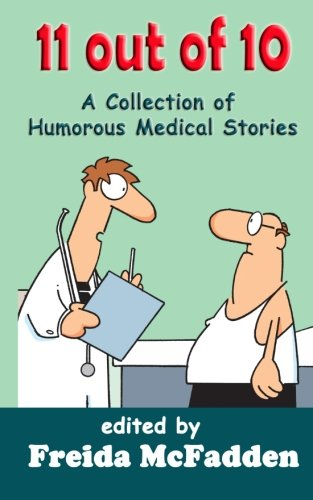Could you suggest similar books or genres that fans of this book might enjoy? Fans of '11 out of 10' might also enjoy other collections of humorous anecdotes from medical fields, such as books by Max Pemberton or the famous 'House of God' by Samuel Shem. They might also appreciate related genres that explore medical humor and realities through a comedic lens. 